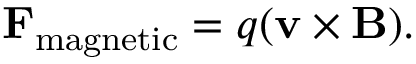<formula> <loc_0><loc_0><loc_500><loc_500>F _ { m a g n e t i c } = q ( v \times B ) .</formula> 